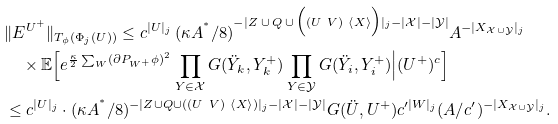Convert formula to latex. <formula><loc_0><loc_0><loc_500><loc_500>& \| E ^ { U ^ { + } } \| _ { T _ { \phi } ( \Phi _ { j } ( U ) ) } \leq c ^ { | U | _ { j } } \, ( \kappa A ^ { ^ { * } } / 8 ) ^ { - | Z \, \cup \, Q \, \cup \, \Big ( ( U \ V ) \ \left \langle X \right \rangle \Big ) | _ { j } - | \mathcal { X } | - | \mathcal { Y } | } A ^ { - | X _ { \mathcal { X } \cup \mathcal { Y } } | _ { j } } \\ & \quad \times \mathbb { E } \Big [ e ^ { \frac { \kappa } { 2 } \sum _ { W } ( \partial P _ { W ^ { + } } \phi ) ^ { 2 } } \prod _ { Y \in \mathcal { X } } G ( \ddot { Y } _ { k } , Y _ { k } ^ { + } ) \prod _ { Y \in \mathcal { Y } } G ( \ddot { Y } _ { i } , Y _ { i } ^ { + } ) \Big | ( U ^ { + } ) ^ { c } \Big ] \\ & \leq c ^ { | U | _ { j } } \cdot ( \kappa A ^ { ^ { * } } / 8 ) ^ { - | Z \cup Q \cup ( ( U \ V ) \ \left \langle X \right \rangle ) | _ { j } - | \mathcal { X } | - | \mathcal { Y } | } G ( \ddot { U } , U ^ { + } ) c ^ { \prime | W | _ { j } } ( A / c ^ { \prime } ) ^ { - | X _ { \mathcal { X } \cup \mathcal { Y } } | _ { j } } .</formula> 